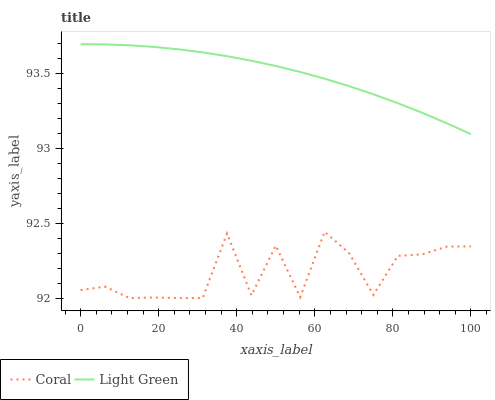Does Coral have the minimum area under the curve?
Answer yes or no. Yes. Does Light Green have the maximum area under the curve?
Answer yes or no. Yes. Does Light Green have the minimum area under the curve?
Answer yes or no. No. Is Light Green the smoothest?
Answer yes or no. Yes. Is Coral the roughest?
Answer yes or no. Yes. Is Light Green the roughest?
Answer yes or no. No. Does Coral have the lowest value?
Answer yes or no. Yes. Does Light Green have the lowest value?
Answer yes or no. No. Does Light Green have the highest value?
Answer yes or no. Yes. Is Coral less than Light Green?
Answer yes or no. Yes. Is Light Green greater than Coral?
Answer yes or no. Yes. Does Coral intersect Light Green?
Answer yes or no. No. 